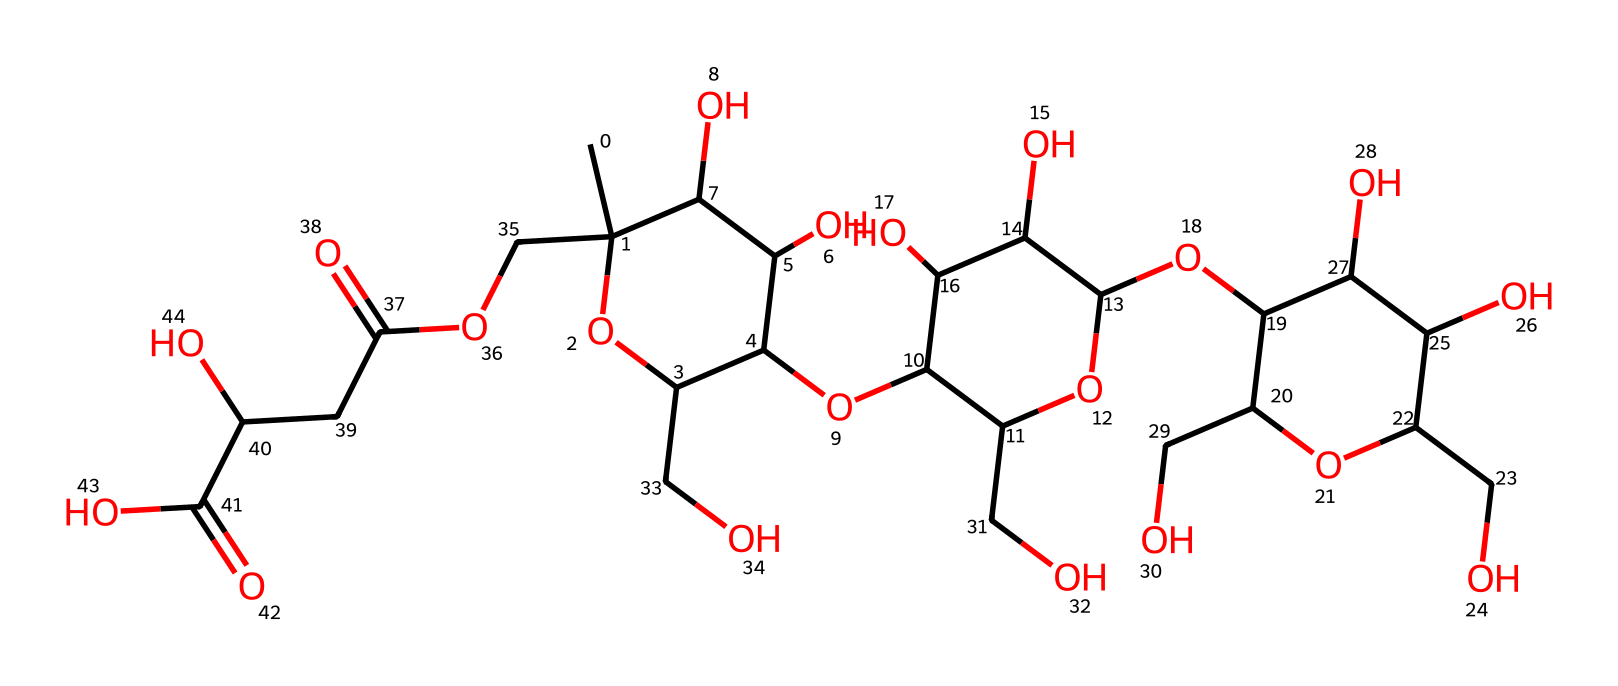What is the main function of xanthan gum in food products? Xanthan gum acts as a thickening agent due to its ability to form a viscous solution in water, which is characteristic of non-Newtonian fluids.
Answer: thickening agent How many carbon atoms are present in the molecular structure of xanthan gum? By analyzing the molecular structure represented in the SMILES format, there are 20 carbon atoms (C) present in the composition of xanthan gum.
Answer: 20 What type of chemical structure does xanthan gum predominantly have? Xanthan gum predominantly has a polysaccharide structure, which consists of long chains of sugar molecules, allowing it to exhibit non-Newtonian fluid behavior.
Answer: polysaccharide Which functional group is responsible for the solubility of xanthan gum in water? The presence of multiple hydroxyl (-OH) groups in the structure of xanthan gum enhances its ability to dissolve in water, resulting in its effective use as a thickening agent.
Answer: hydroxyl How does xanthan gum behave under shear stress? Xanthan gum exhibits shear-thinning behavior, meaning it decreases in viscosity when subjected to shear stress, which is a defining characteristic of non-Newtonian fluids.
Answer: shear-thinning What is the effect of temperature on the viscosity of xanthan gum solutions? Xanthan gum solutions typically show a slight decrease in viscosity with an increase in temperature, which is common for many polysaccharides.
Answer: slight decrease 